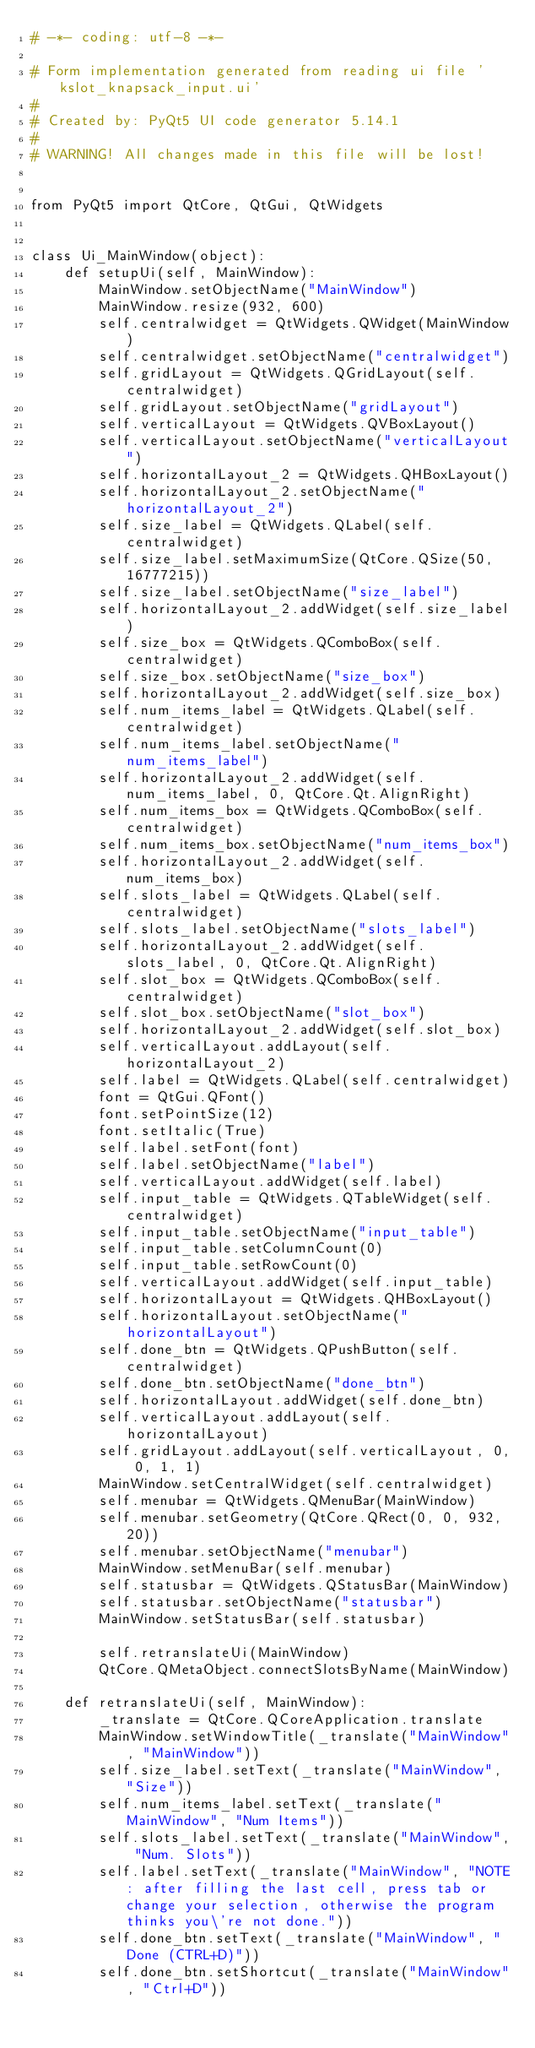Convert code to text. <code><loc_0><loc_0><loc_500><loc_500><_Python_># -*- coding: utf-8 -*-

# Form implementation generated from reading ui file 'kslot_knapsack_input.ui'
#
# Created by: PyQt5 UI code generator 5.14.1
#
# WARNING! All changes made in this file will be lost!


from PyQt5 import QtCore, QtGui, QtWidgets


class Ui_MainWindow(object):
    def setupUi(self, MainWindow):
        MainWindow.setObjectName("MainWindow")
        MainWindow.resize(932, 600)
        self.centralwidget = QtWidgets.QWidget(MainWindow)
        self.centralwidget.setObjectName("centralwidget")
        self.gridLayout = QtWidgets.QGridLayout(self.centralwidget)
        self.gridLayout.setObjectName("gridLayout")
        self.verticalLayout = QtWidgets.QVBoxLayout()
        self.verticalLayout.setObjectName("verticalLayout")
        self.horizontalLayout_2 = QtWidgets.QHBoxLayout()
        self.horizontalLayout_2.setObjectName("horizontalLayout_2")
        self.size_label = QtWidgets.QLabel(self.centralwidget)
        self.size_label.setMaximumSize(QtCore.QSize(50, 16777215))
        self.size_label.setObjectName("size_label")
        self.horizontalLayout_2.addWidget(self.size_label)
        self.size_box = QtWidgets.QComboBox(self.centralwidget)
        self.size_box.setObjectName("size_box")
        self.horizontalLayout_2.addWidget(self.size_box)
        self.num_items_label = QtWidgets.QLabel(self.centralwidget)
        self.num_items_label.setObjectName("num_items_label")
        self.horizontalLayout_2.addWidget(self.num_items_label, 0, QtCore.Qt.AlignRight)
        self.num_items_box = QtWidgets.QComboBox(self.centralwidget)
        self.num_items_box.setObjectName("num_items_box")
        self.horizontalLayout_2.addWidget(self.num_items_box)
        self.slots_label = QtWidgets.QLabel(self.centralwidget)
        self.slots_label.setObjectName("slots_label")
        self.horizontalLayout_2.addWidget(self.slots_label, 0, QtCore.Qt.AlignRight)
        self.slot_box = QtWidgets.QComboBox(self.centralwidget)
        self.slot_box.setObjectName("slot_box")
        self.horizontalLayout_2.addWidget(self.slot_box)
        self.verticalLayout.addLayout(self.horizontalLayout_2)
        self.label = QtWidgets.QLabel(self.centralwidget)
        font = QtGui.QFont()
        font.setPointSize(12)
        font.setItalic(True)
        self.label.setFont(font)
        self.label.setObjectName("label")
        self.verticalLayout.addWidget(self.label)
        self.input_table = QtWidgets.QTableWidget(self.centralwidget)
        self.input_table.setObjectName("input_table")
        self.input_table.setColumnCount(0)
        self.input_table.setRowCount(0)
        self.verticalLayout.addWidget(self.input_table)
        self.horizontalLayout = QtWidgets.QHBoxLayout()
        self.horizontalLayout.setObjectName("horizontalLayout")
        self.done_btn = QtWidgets.QPushButton(self.centralwidget)
        self.done_btn.setObjectName("done_btn")
        self.horizontalLayout.addWidget(self.done_btn)
        self.verticalLayout.addLayout(self.horizontalLayout)
        self.gridLayout.addLayout(self.verticalLayout, 0, 0, 1, 1)
        MainWindow.setCentralWidget(self.centralwidget)
        self.menubar = QtWidgets.QMenuBar(MainWindow)
        self.menubar.setGeometry(QtCore.QRect(0, 0, 932, 20))
        self.menubar.setObjectName("menubar")
        MainWindow.setMenuBar(self.menubar)
        self.statusbar = QtWidgets.QStatusBar(MainWindow)
        self.statusbar.setObjectName("statusbar")
        MainWindow.setStatusBar(self.statusbar)

        self.retranslateUi(MainWindow)
        QtCore.QMetaObject.connectSlotsByName(MainWindow)

    def retranslateUi(self, MainWindow):
        _translate = QtCore.QCoreApplication.translate
        MainWindow.setWindowTitle(_translate("MainWindow", "MainWindow"))
        self.size_label.setText(_translate("MainWindow", "Size"))
        self.num_items_label.setText(_translate("MainWindow", "Num Items"))
        self.slots_label.setText(_translate("MainWindow", "Num. Slots"))
        self.label.setText(_translate("MainWindow", "NOTE: after filling the last cell, press tab or change your selection, otherwise the program thinks you\'re not done."))
        self.done_btn.setText(_translate("MainWindow", "Done (CTRL+D)"))
        self.done_btn.setShortcut(_translate("MainWindow", "Ctrl+D"))
</code> 